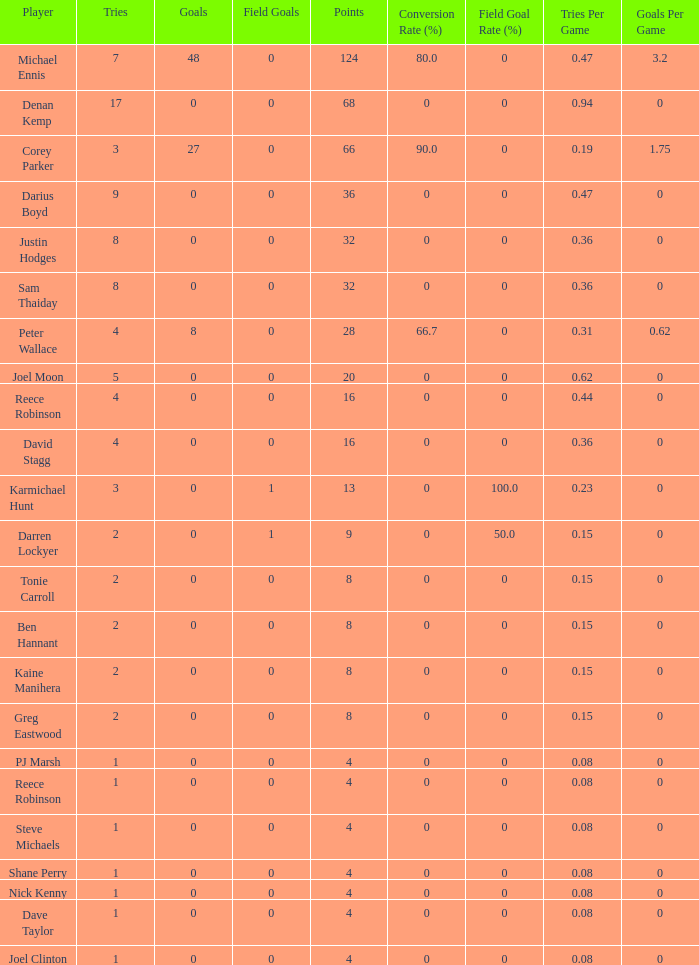What is the lowest tries the player with more than 0 goals, 28 points, and more than 0 field goals have? None. 